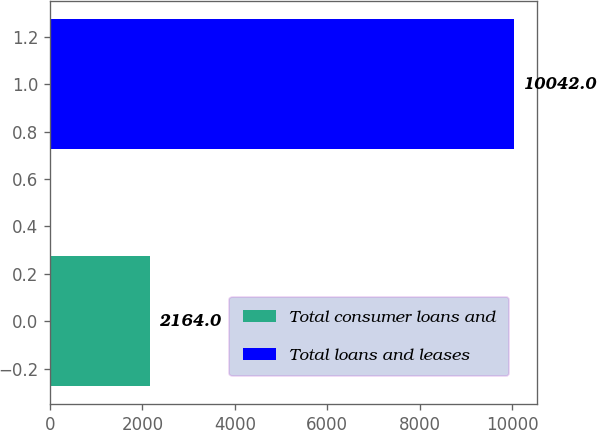<chart> <loc_0><loc_0><loc_500><loc_500><bar_chart><fcel>Total consumer loans and<fcel>Total loans and leases<nl><fcel>2164<fcel>10042<nl></chart> 